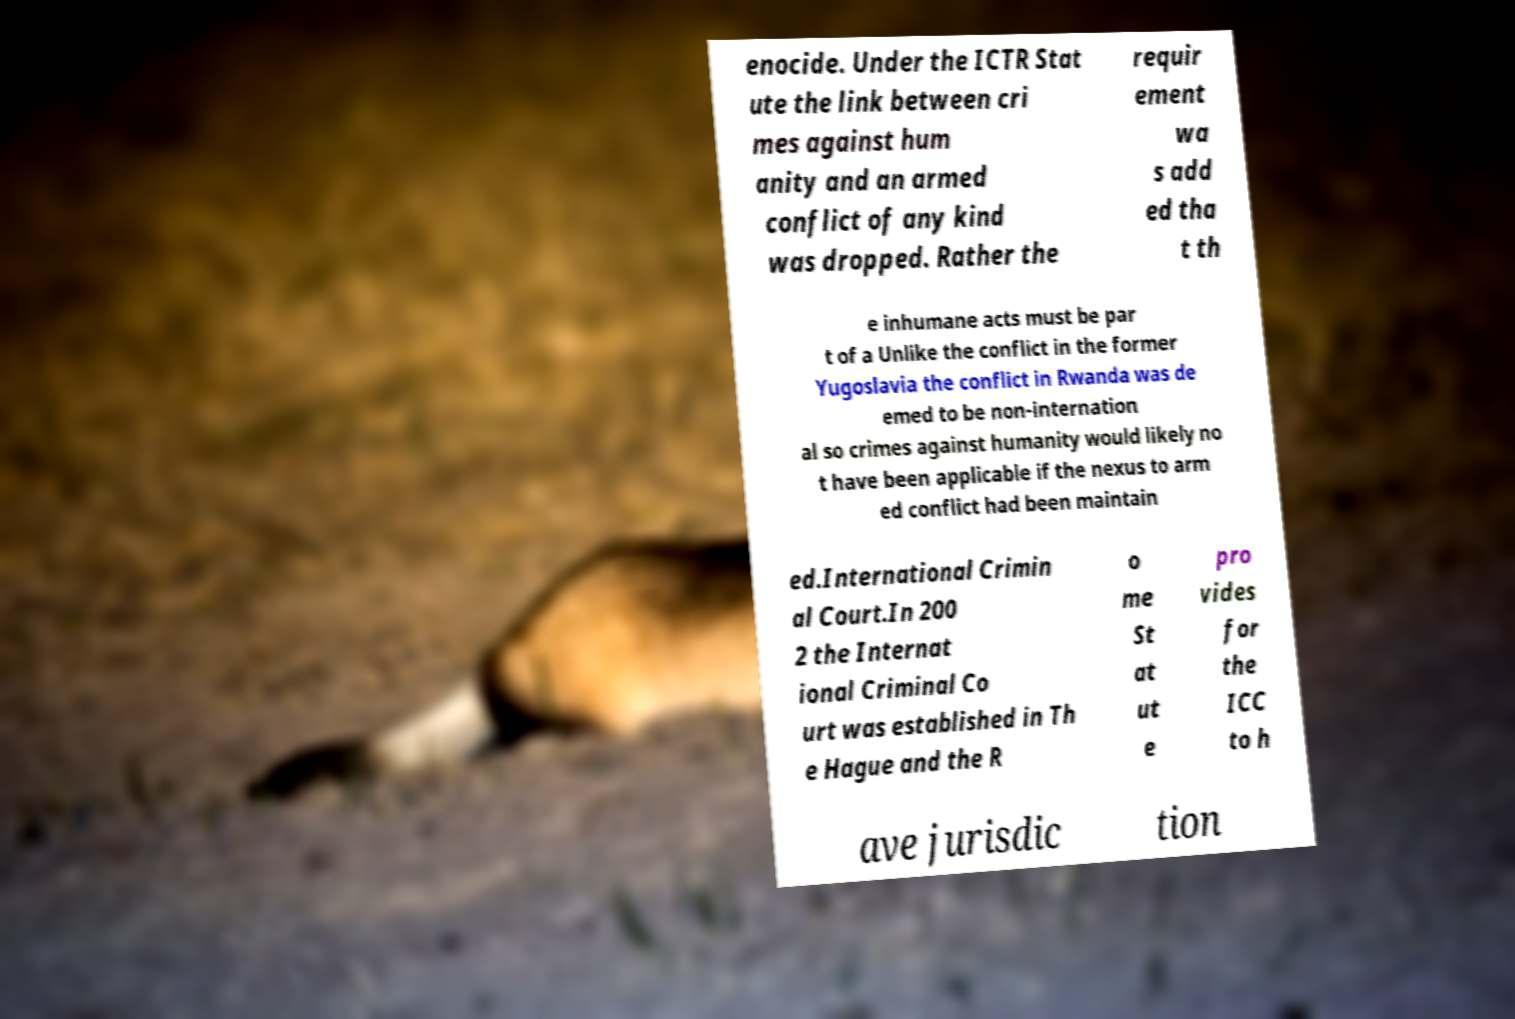Please read and relay the text visible in this image. What does it say? enocide. Under the ICTR Stat ute the link between cri mes against hum anity and an armed conflict of any kind was dropped. Rather the requir ement wa s add ed tha t th e inhumane acts must be par t of a Unlike the conflict in the former Yugoslavia the conflict in Rwanda was de emed to be non-internation al so crimes against humanity would likely no t have been applicable if the nexus to arm ed conflict had been maintain ed.International Crimin al Court.In 200 2 the Internat ional Criminal Co urt was established in Th e Hague and the R o me St at ut e pro vides for the ICC to h ave jurisdic tion 